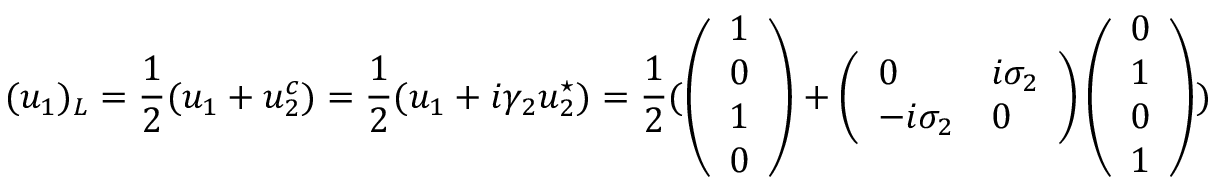Convert formula to latex. <formula><loc_0><loc_0><loc_500><loc_500>( u _ { 1 } ) _ { L } = \frac { 1 } { 2 } ( u _ { 1 } + u _ { 2 } ^ { c } ) = \frac { 1 } { 2 } ( u _ { 1 } + i \gamma _ { 2 } u _ { 2 } ^ { ^ { * } } ) = \frac { 1 } { 2 } ( \left ( \begin{array} { l } { 1 } \\ { 0 } \\ { 1 } \\ { 0 } \end{array} \right ) + \left ( \begin{array} { l l } { 0 } & { i \sigma _ { 2 } } \\ { - i \sigma _ { 2 } } & { 0 } \end{array} \right ) \left ( \begin{array} { l } { 0 } \\ { 1 } \\ { 0 } \\ { 1 } \end{array} \right ) )</formula> 